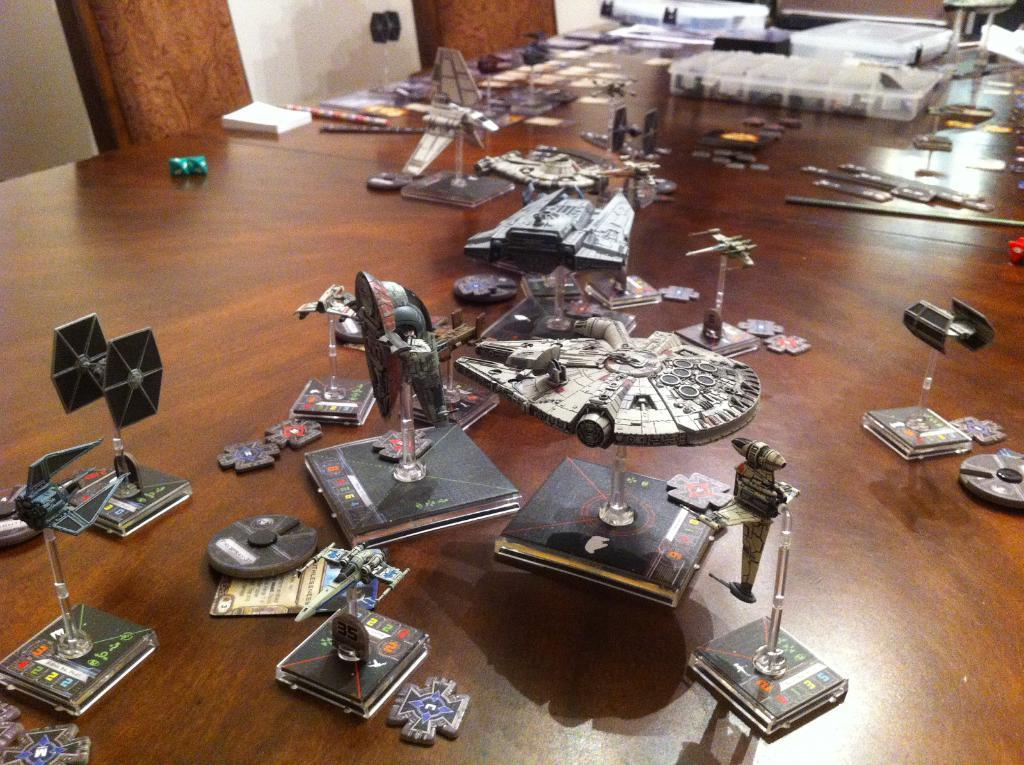What is on the table in the image? There are books and other objects on the table in the image. Can you describe the other objects on the table? Unfortunately, the provided facts do not specify the nature of the other objects on the table. What type of furniture is visible in the image? There are chairs in the image. What can be seen in the background of the image? There is a wall in the background of the image. How many memories are stacked on the table in the image? Memories are not physical objects that can be stacked on a table. The image contains books and other objects, but not memories. Is there a parcel being delivered in the image? The provided facts do not mention a parcel or any delivery in the image. 